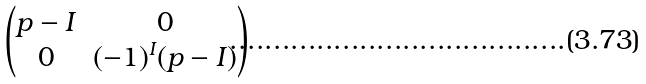Convert formula to latex. <formula><loc_0><loc_0><loc_500><loc_500>\begin{pmatrix} p - I & 0 \\ 0 & ( - 1 ) ^ { I } ( p - I ) \end{pmatrix}</formula> 